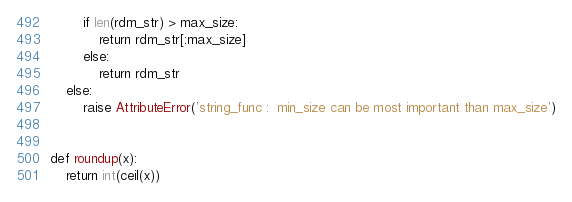Convert code to text. <code><loc_0><loc_0><loc_500><loc_500><_Python_>        if len(rdm_str) > max_size:
            return rdm_str[:max_size]
        else:
            return rdm_str
    else:
        raise AttributeError('string_func :  min_size can be most important than max_size')


def roundup(x):
    return int(ceil(x))
</code> 